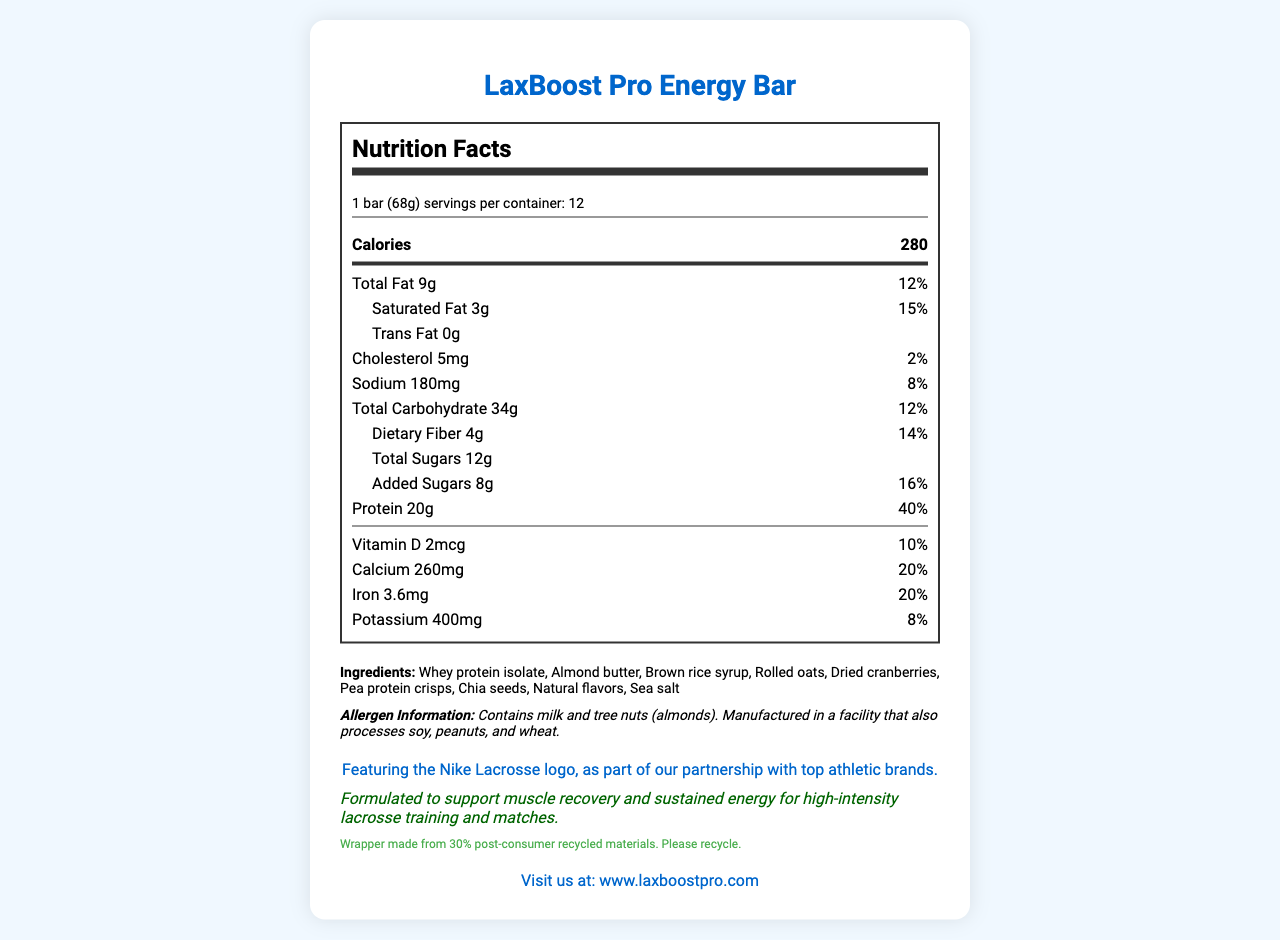what is the serving size of the LaxBoost Pro Energy Bar? The serving size is listed as "1 bar (68g)" at the top of the Nutrition Facts section.
Answer: 1 bar (68g) how many servings are there per container? The document mentions that there are 12 servings per container.
Answer: 12 how many calories are in one serving of the LaxBoost Pro Energy Bar? It is written in the main section under "Calories" that one serving contains 280 calories.
Answer: 280 how much protein does one bar contain? The amount of protein per bar is listed as 20g in the nutrition facts.
Answer: 20g what are the ingredients in the LaxBoost Pro Energy Bar? The ingredients are listed at the bottom of the Nutrition Facts label.
Answer: Whey protein isolate, Almond butter, Brown rice syrup, Rolled oats, Dried cranberries, Pea protein crisps, Chia seeds, Natural flavors, Sea salt what percentage of daily value is the calcium in the LaxBoost Pro Energy Bar? For calcium, the daily value percentage is mentioned as 20%.
Answer: 20% How much added sugar is in one serving? The amount of added sugars per serving is 8g as reflected in the Nutrition Facts label.
Answer: 8g Is there any trans fat in the LaxBoost Pro Energy Bar? The label states "Trans Fat 0g," indicating that there is no trans fat in the bar.
Answer: No Which ingredients contain potential allergens? The allergen information lists milk and tree nuts (almonds) as potential allergens.
Answer: Milk and tree nuts (almonds) What is the approximate weight of one LaxBoost Pro Energy Bar? A. 50g B. 68g C. 75g D. 100g The serving size, which is equivalent to one bar, is mentioned as 68g.
Answer: B. 68g What is the notable feature of the packaging design? A. Green and gold colors B. Stylized lacrosse stick and ball design C. Striped pattern D. Transparent wrapper The packaging is described as featuring a "stylized lacrosse stick and ball design."
Answer: B. Stylized lacrosse stick and ball design Does the product marketing emphasize muscle recovery? (Yes/No) The athletic claim states that the bar is formulated to support muscle recovery.
Answer: Yes Give a brief summary of the LaxBoost Pro Energy Bar document. The explanation encompasses all the main points of the document including nutrition facts, ingredients, allergen info, branding, packaging, athletic claims, and sustainability notes.
Answer: The document provides comprehensive nutritional information for the LaxBoost Pro Energy Bar. It includes serving size, servings per container, calories, and detailed nutrient contents like fats, cholesterol, sodium, carbohydrates, sugars, protein, and various vitamins and minerals. The ingredients and allergen information are clearly stated. The packaging is described as lacrosse-themed, and the product is promoted for its muscle recovery benefits due to its high protein content. Sustainability measures are mentioned, and the product is co-branded with Nike Lacrosse. What is the price of one container of LaxBoost Pro Energy Bars? The document does not provide any information about the price of the product, so this question cannot be answered based on the visible information.
Answer: Cannot be determined 